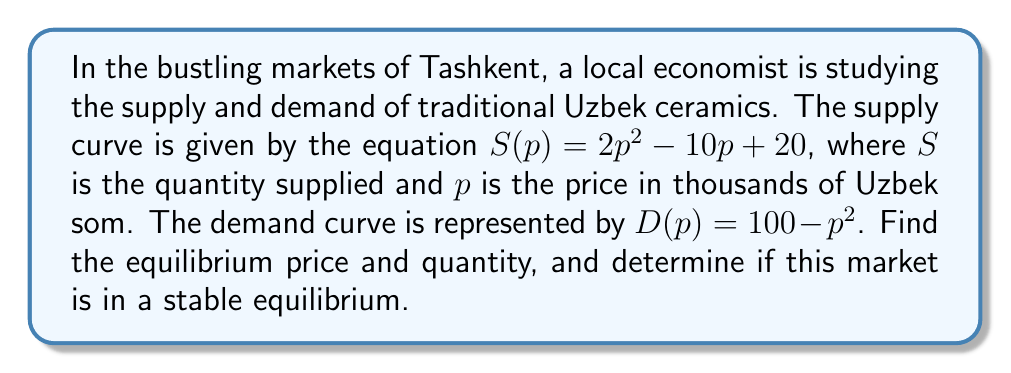Help me with this question. Let's approach this step-by-step:

1) At equilibrium, supply equals demand. So we need to solve:

   $$S(p) = D(p)$$
   $$2p^2 - 10p + 20 = 100 - p^2$$

2) Rearranging the equation:

   $$3p^2 - 10p - 80 = 0$$

3) This is a quadratic equation. We can solve it using the quadratic formula:
   $$p = \frac{-b \pm \sqrt{b^2 - 4ac}}{2a}$$
   where $a=3$, $b=-10$, and $c=-80$

4) Substituting these values:

   $$p = \frac{10 \pm \sqrt{(-10)^2 - 4(3)(-80)}}{2(3)}$$
   $$= \frac{10 \pm \sqrt{100 + 960}}{6}$$
   $$= \frac{10 \pm \sqrt{1060}}{6}$$

5) Simplifying:

   $$p \approx 6.76 \text{ or } p \approx -3.43$$

6) Since price can't be negative, we discard the negative solution.

7) The equilibrium price is approximately 6.76 thousand som.

8) To find the equilibrium quantity, we can substitute this price into either the supply or demand function:

   $$Q = S(6.76) = 2(6.76)^2 - 10(6.76) + 20 \approx 41.39$$

9) To determine if this is a stable equilibrium, we need to check the slopes of supply and demand curves at the equilibrium point:

   $$\frac{dS}{dp} = 4p - 10$$
   $$\frac{dD}{dp} = -2p$$

   At $p = 6.76$:
   $$\frac{dS}{dp} \approx 17.04$$
   $$\frac{dD}{dp} \approx -13.52$$

   Since the slope of the supply curve is greater than the slope of the demand curve at the equilibrium point, this is a stable equilibrium.
Answer: Equilibrium price ≈ 6.76 thousand som, quantity ≈ 41.39 units; stable equilibrium. 